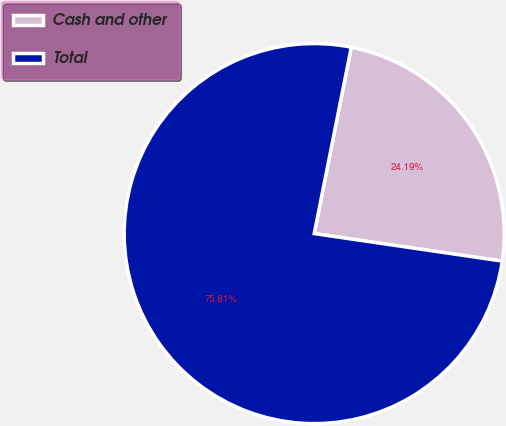Convert chart. <chart><loc_0><loc_0><loc_500><loc_500><pie_chart><fcel>Cash and other<fcel>Total<nl><fcel>24.19%<fcel>75.81%<nl></chart> 